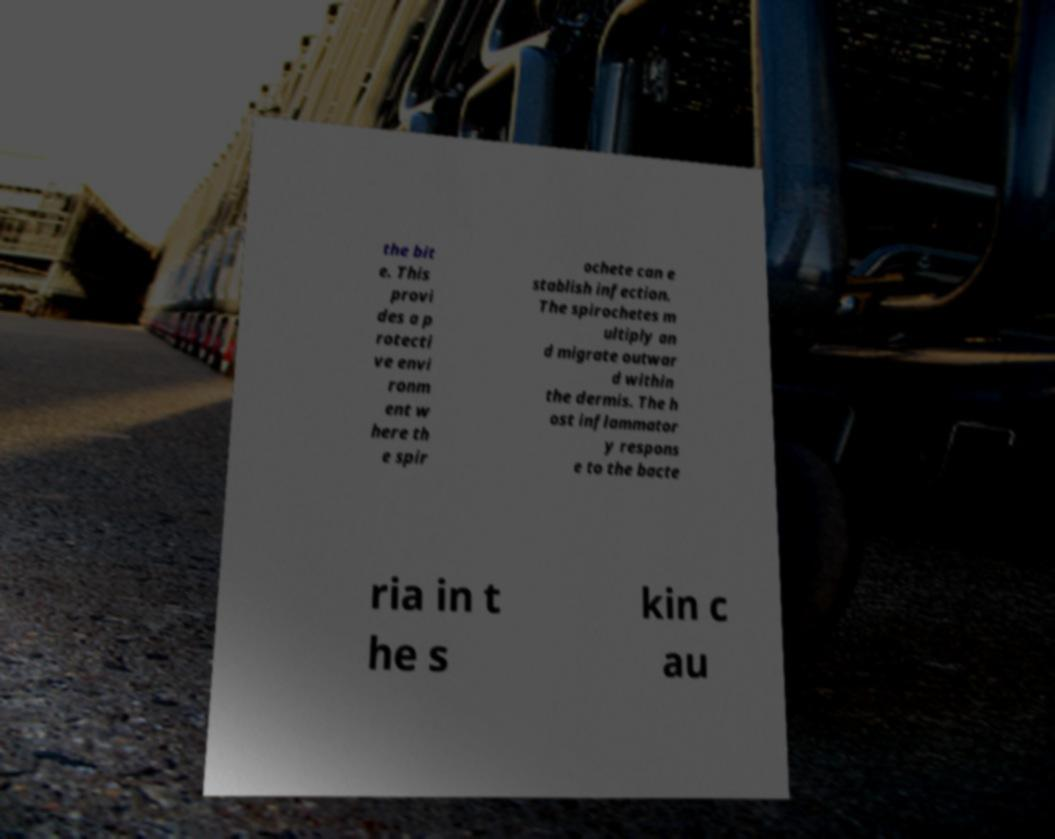Can you read and provide the text displayed in the image?This photo seems to have some interesting text. Can you extract and type it out for me? the bit e. This provi des a p rotecti ve envi ronm ent w here th e spir ochete can e stablish infection. The spirochetes m ultiply an d migrate outwar d within the dermis. The h ost inflammator y respons e to the bacte ria in t he s kin c au 